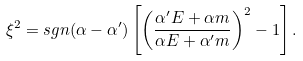<formula> <loc_0><loc_0><loc_500><loc_500>\xi ^ { 2 } = s g n ( \alpha - \alpha ^ { \prime } ) \left [ \left ( \frac { \alpha { ^ { \prime } } E + \alpha { m } } { \alpha { E } + \alpha { ^ { \prime } } m } \right ) ^ { 2 } - 1 \right ] .</formula> 